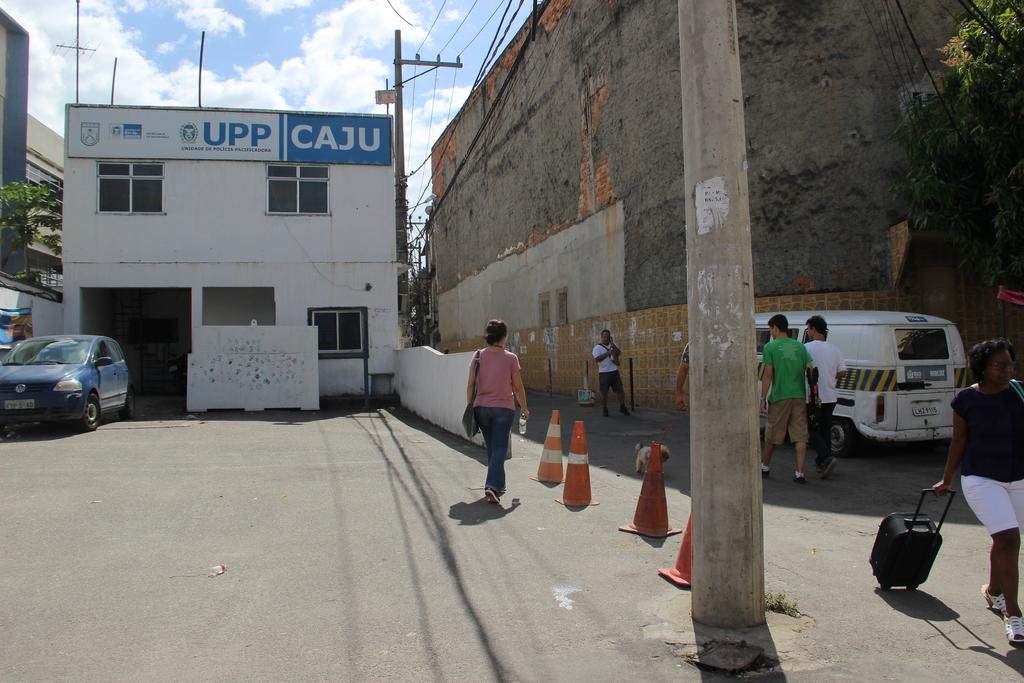<image>
Give a short and clear explanation of the subsequent image. A building that has UPP written on a banner at the top of it. 